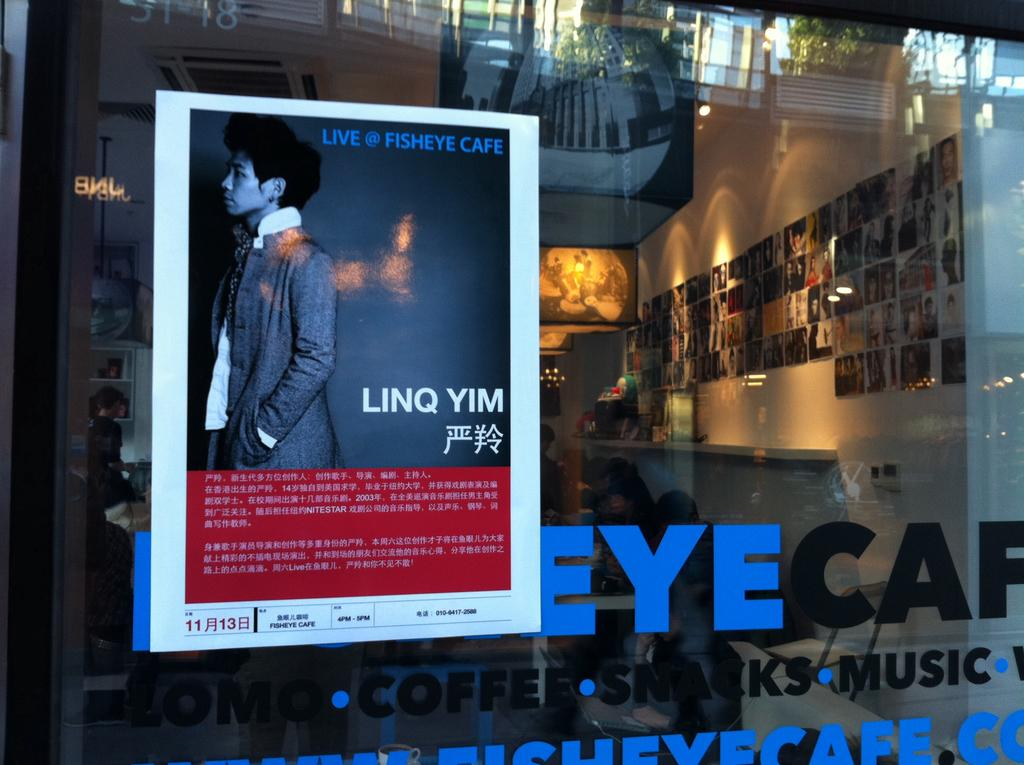Provide a one-sentence caption for the provided image. A poster advertising that Linq Yim is going to be at the Fisheye Cafe is on the window on that cafe. 